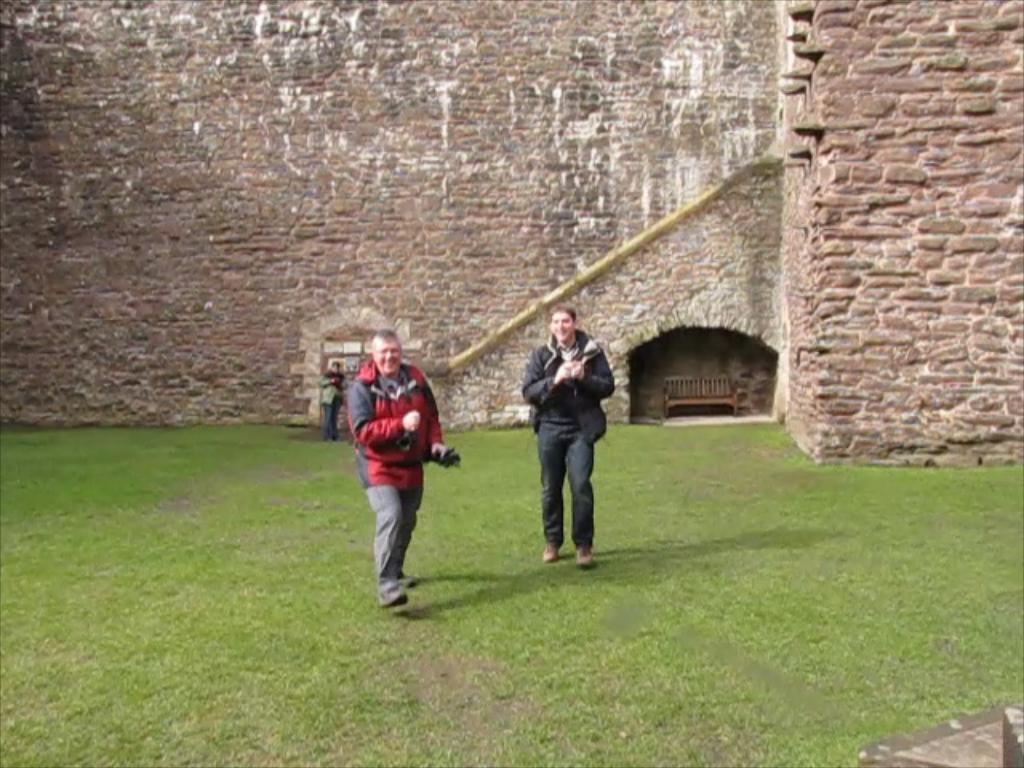Describe this image in one or two sentences. In this image, there are three people standing on the grass. In the background, I can see a wall and a wooden bench. 